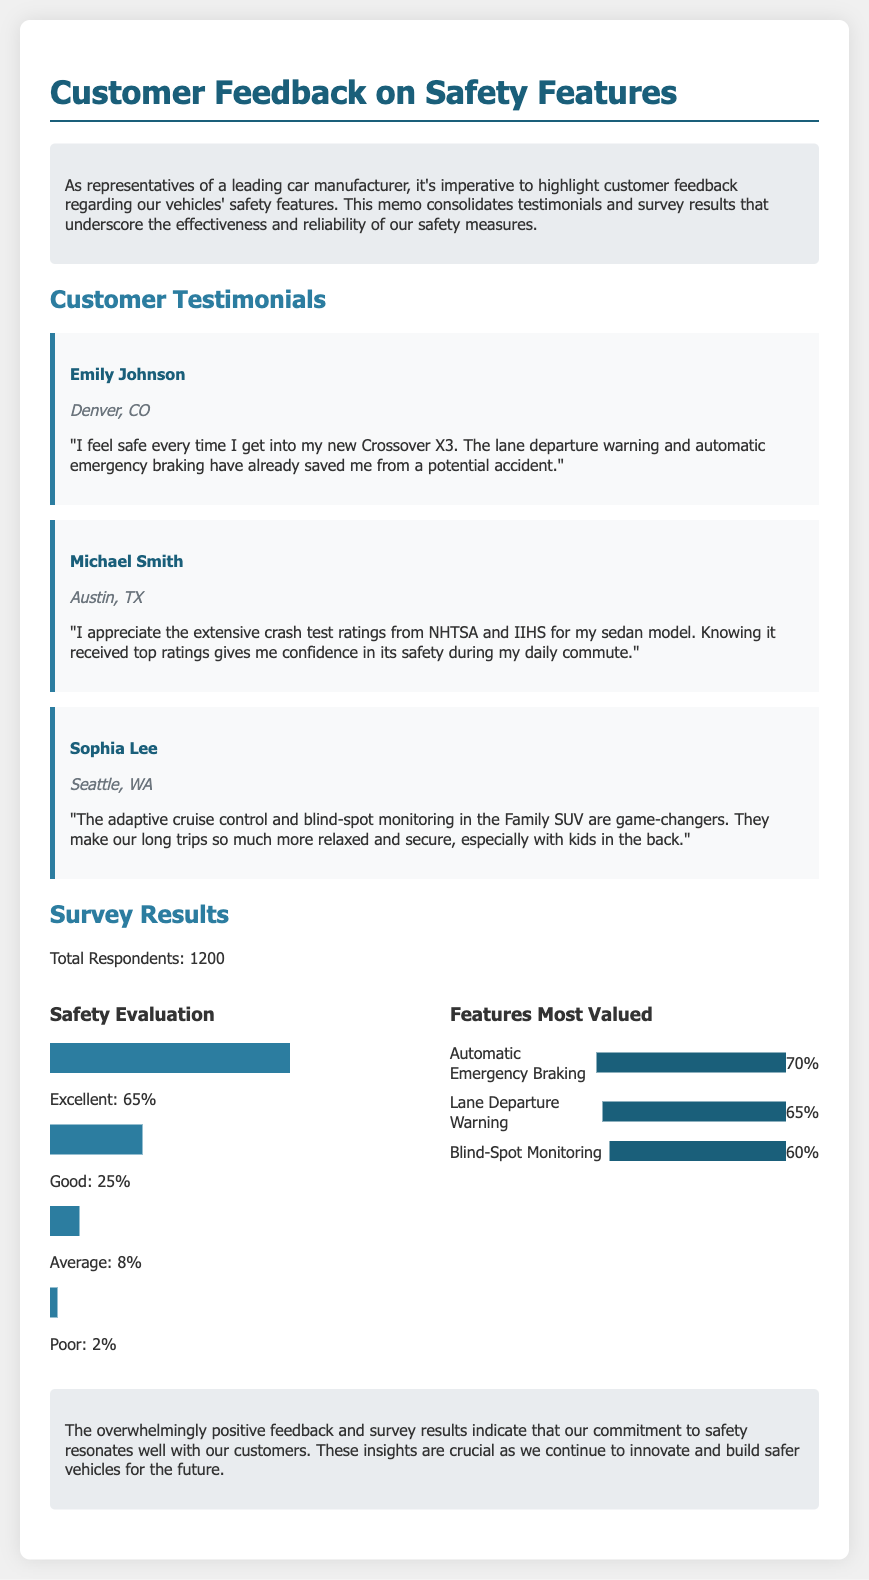what is the total number of survey respondents? The total number of survey respondents is clearly stated in the survey results section of the document.
Answer: 1200 who provided a testimonial from Denver, CO? The customer testimonial section lists Emily Johnson as the person from Denver, CO.
Answer: Emily Johnson what percentage of respondents rated safety as excellent? The safety evaluation section provides the percentage of respondents who rated safety as excellent.
Answer: 65% which safety feature was valued the most by respondents? The survey results detail the features most valued, with Automatic Emergency Braking at the top.
Answer: Automatic Emergency Braking what is the main purpose of the memo? The introduction clearly outlines the purpose of the memo as highlighting customer feedback on safety features.
Answer: Highlight customer feedback what percentage of respondents rated safety as poor? The survey results include the percentage of respondents who rated safety as poor.
Answer: 2% who mentioned the extensive crash test ratings? Michael Smith is the customer who expressed appreciation for the extensive crash test ratings.
Answer: Michael Smith which vehicle model did Sophia Lee refer to in her testimonial? Sophia Lee's testimonial mentions the Family SUV as the vehicle model.
Answer: Family SUV 